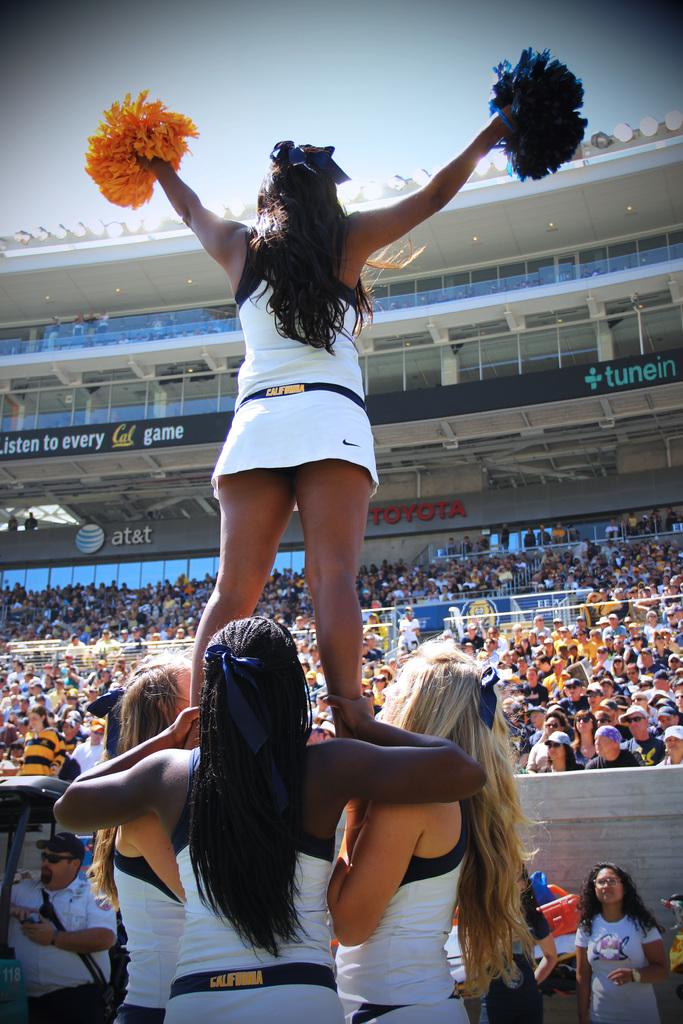What are the sponsors on the stadium?
Your response must be concise. Tunein. 